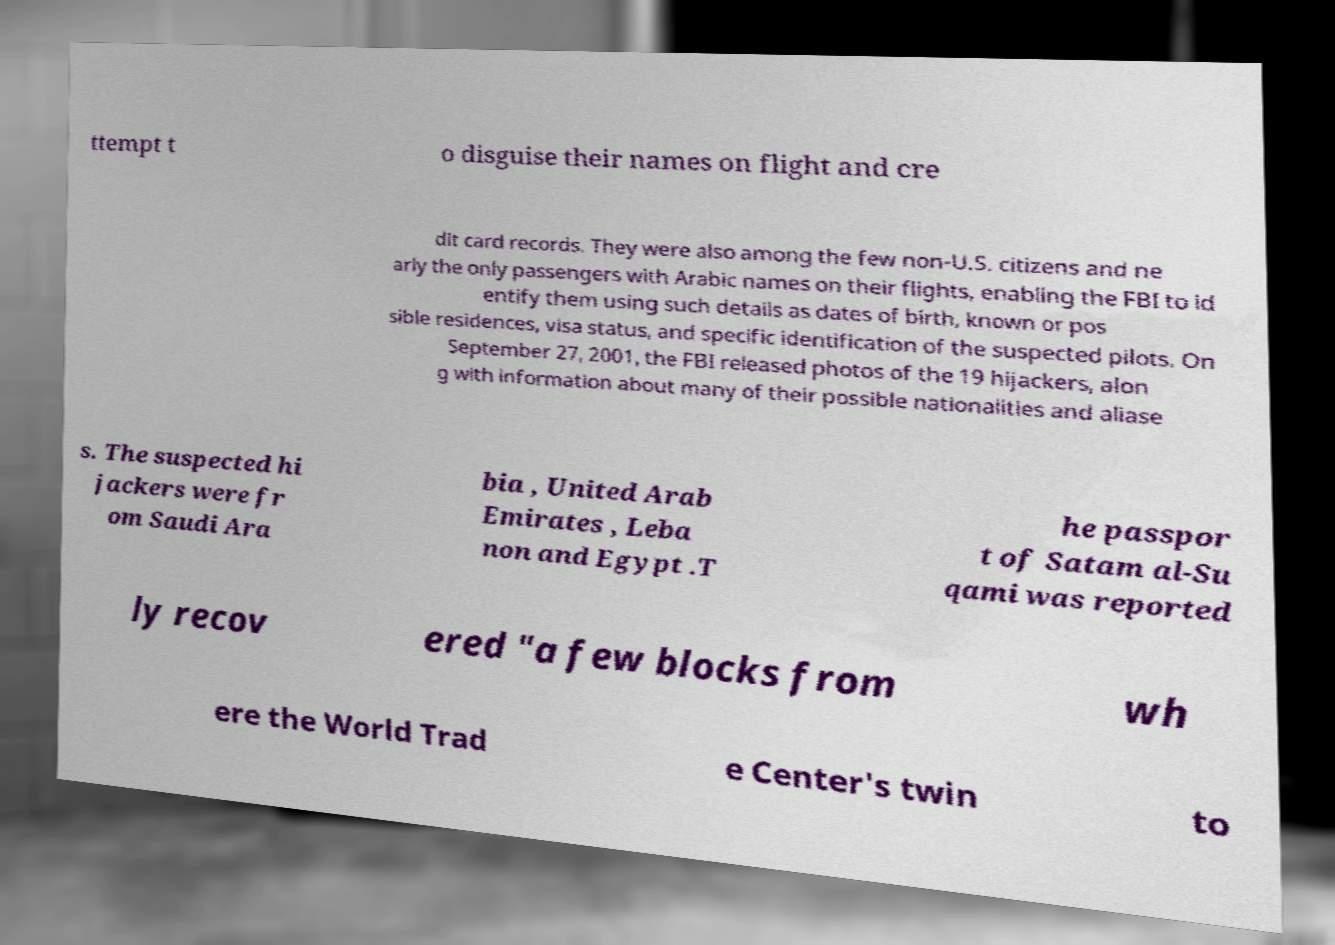Can you read and provide the text displayed in the image?This photo seems to have some interesting text. Can you extract and type it out for me? ttempt t o disguise their names on flight and cre dit card records. They were also among the few non-U.S. citizens and ne arly the only passengers with Arabic names on their flights, enabling the FBI to id entify them using such details as dates of birth, known or pos sible residences, visa status, and specific identification of the suspected pilots. On September 27, 2001, the FBI released photos of the 19 hijackers, alon g with information about many of their possible nationalities and aliase s. The suspected hi jackers were fr om Saudi Ara bia , United Arab Emirates , Leba non and Egypt .T he passpor t of Satam al-Su qami was reported ly recov ered "a few blocks from wh ere the World Trad e Center's twin to 